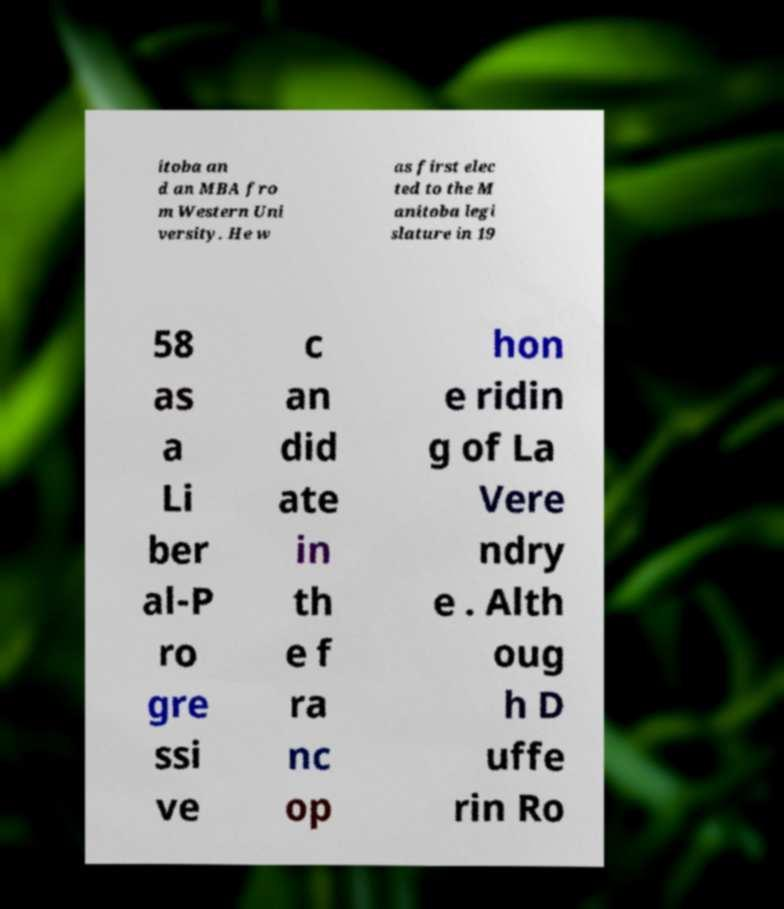For documentation purposes, I need the text within this image transcribed. Could you provide that? itoba an d an MBA fro m Western Uni versity. He w as first elec ted to the M anitoba legi slature in 19 58 as a Li ber al-P ro gre ssi ve c an did ate in th e f ra nc op hon e ridin g of La Vere ndry e . Alth oug h D uffe rin Ro 